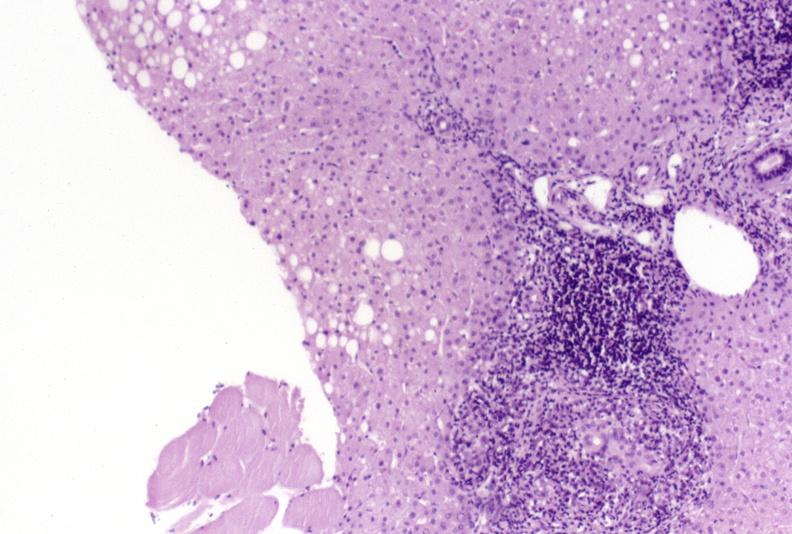what is present?
Answer the question using a single word or phrase. Liver 